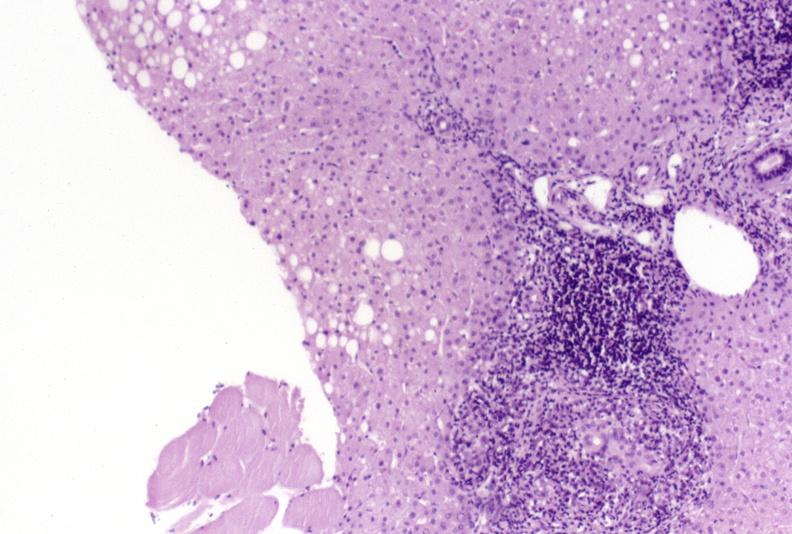what is present?
Answer the question using a single word or phrase. Liver 